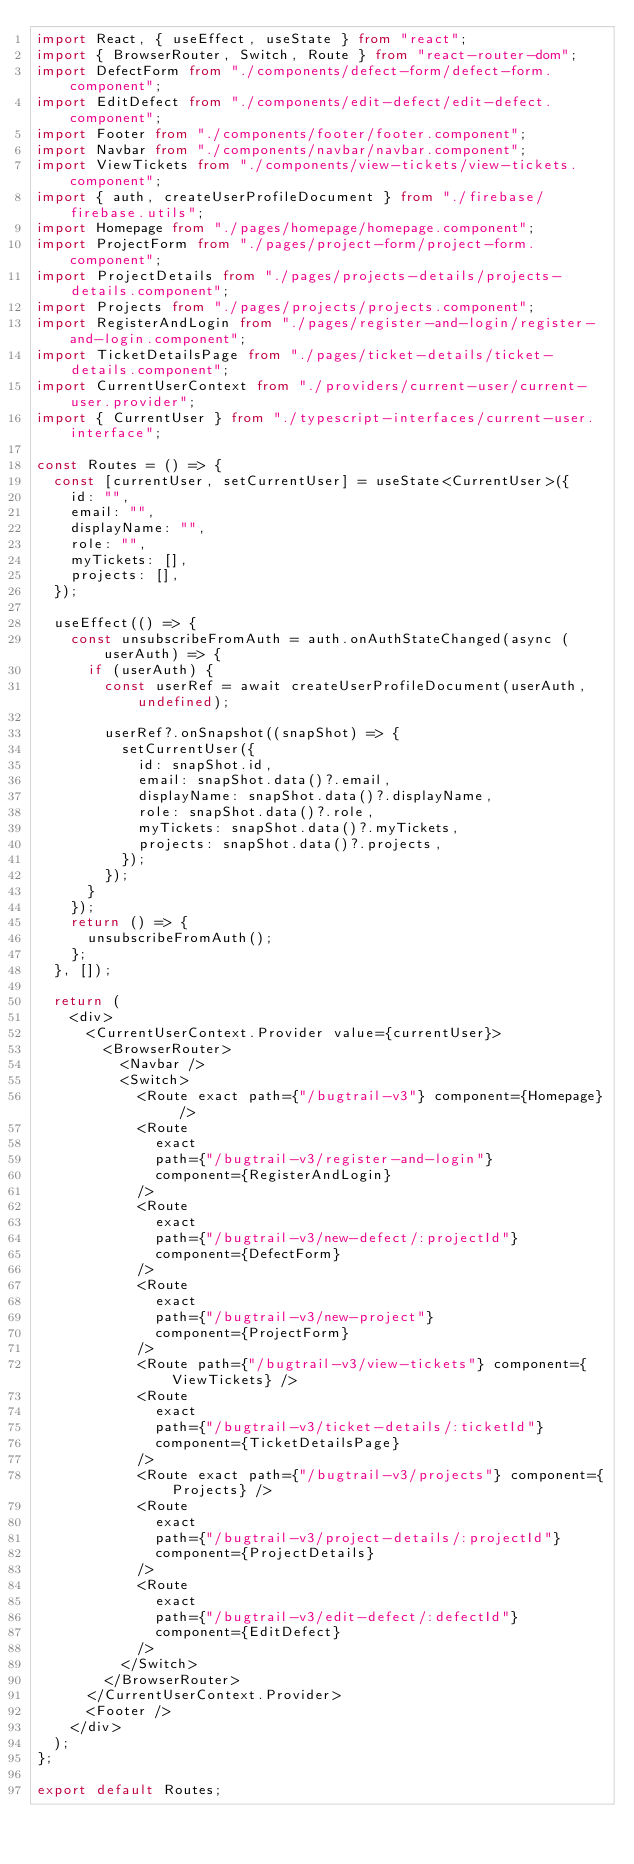Convert code to text. <code><loc_0><loc_0><loc_500><loc_500><_TypeScript_>import React, { useEffect, useState } from "react";
import { BrowserRouter, Switch, Route } from "react-router-dom";
import DefectForm from "./components/defect-form/defect-form.component";
import EditDefect from "./components/edit-defect/edit-defect.component";
import Footer from "./components/footer/footer.component";
import Navbar from "./components/navbar/navbar.component";
import ViewTickets from "./components/view-tickets/view-tickets.component";
import { auth, createUserProfileDocument } from "./firebase/firebase.utils";
import Homepage from "./pages/homepage/homepage.component";
import ProjectForm from "./pages/project-form/project-form.component";
import ProjectDetails from "./pages/projects-details/projects-details.component";
import Projects from "./pages/projects/projects.component";
import RegisterAndLogin from "./pages/register-and-login/register-and-login.component";
import TicketDetailsPage from "./pages/ticket-details/ticket-details.component";
import CurrentUserContext from "./providers/current-user/current-user.provider";
import { CurrentUser } from "./typescript-interfaces/current-user.interface";

const Routes = () => {
  const [currentUser, setCurrentUser] = useState<CurrentUser>({
    id: "",
    email: "",
    displayName: "",
    role: "",
    myTickets: [],
    projects: [],
  });

  useEffect(() => {
    const unsubscribeFromAuth = auth.onAuthStateChanged(async (userAuth) => {
      if (userAuth) {
        const userRef = await createUserProfileDocument(userAuth, undefined);

        userRef?.onSnapshot((snapShot) => {
          setCurrentUser({
            id: snapShot.id,
            email: snapShot.data()?.email,
            displayName: snapShot.data()?.displayName,
            role: snapShot.data()?.role,
            myTickets: snapShot.data()?.myTickets,
            projects: snapShot.data()?.projects,
          });
        });
      }
    });
    return () => {
      unsubscribeFromAuth();
    };
  }, []);

  return (
    <div>
      <CurrentUserContext.Provider value={currentUser}>
        <BrowserRouter>
          <Navbar />
          <Switch>
            <Route exact path={"/bugtrail-v3"} component={Homepage} />
            <Route
              exact
              path={"/bugtrail-v3/register-and-login"}
              component={RegisterAndLogin}
            />
            <Route
              exact
              path={"/bugtrail-v3/new-defect/:projectId"}
              component={DefectForm}
            />
            <Route
              exact
              path={"/bugtrail-v3/new-project"}
              component={ProjectForm}
            />
            <Route path={"/bugtrail-v3/view-tickets"} component={ViewTickets} />
            <Route
              exact
              path={"/bugtrail-v3/ticket-details/:ticketId"}
              component={TicketDetailsPage}
            />
            <Route exact path={"/bugtrail-v3/projects"} component={Projects} />
            <Route
              exact
              path={"/bugtrail-v3/project-details/:projectId"}
              component={ProjectDetails}
            />
            <Route
              exact
              path={"/bugtrail-v3/edit-defect/:defectId"}
              component={EditDefect}
            />
          </Switch>
        </BrowserRouter>
      </CurrentUserContext.Provider>
      <Footer />
    </div>
  );
};

export default Routes;
</code> 